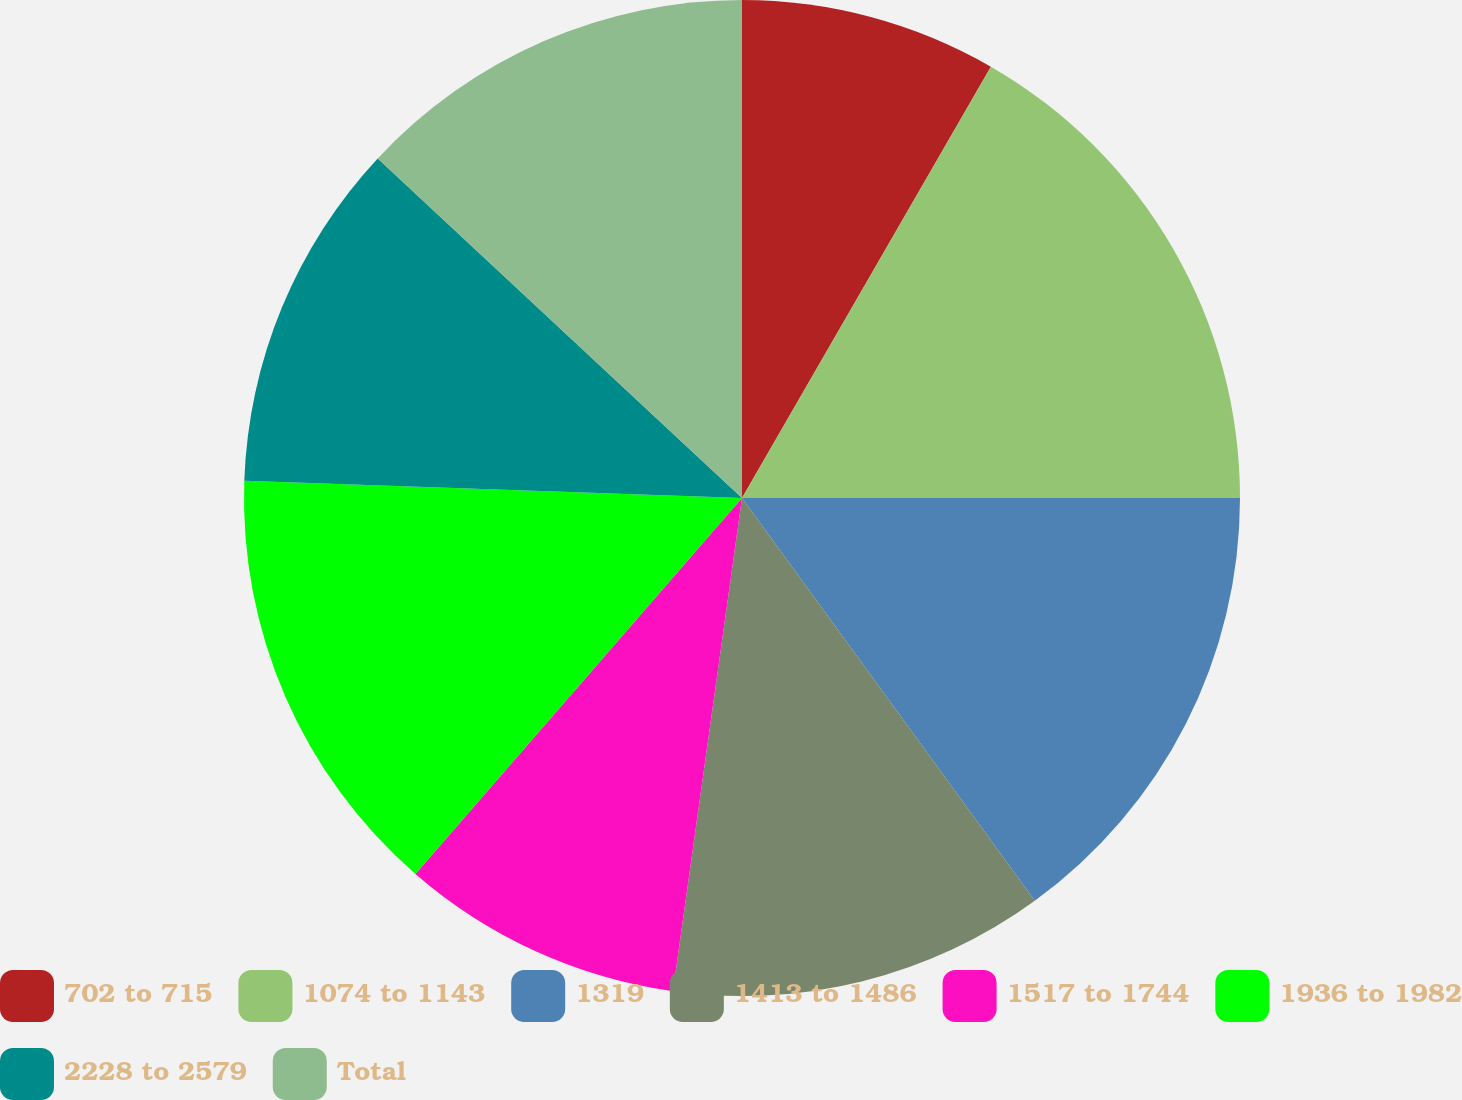Convert chart to OTSL. <chart><loc_0><loc_0><loc_500><loc_500><pie_chart><fcel>702 to 715<fcel>1074 to 1143<fcel>1319<fcel>1413 to 1486<fcel>1517 to 1744<fcel>1936 to 1982<fcel>2228 to 2579<fcel>Total<nl><fcel>8.33%<fcel>16.67%<fcel>15.0%<fcel>12.22%<fcel>9.17%<fcel>14.17%<fcel>11.39%<fcel>13.06%<nl></chart> 